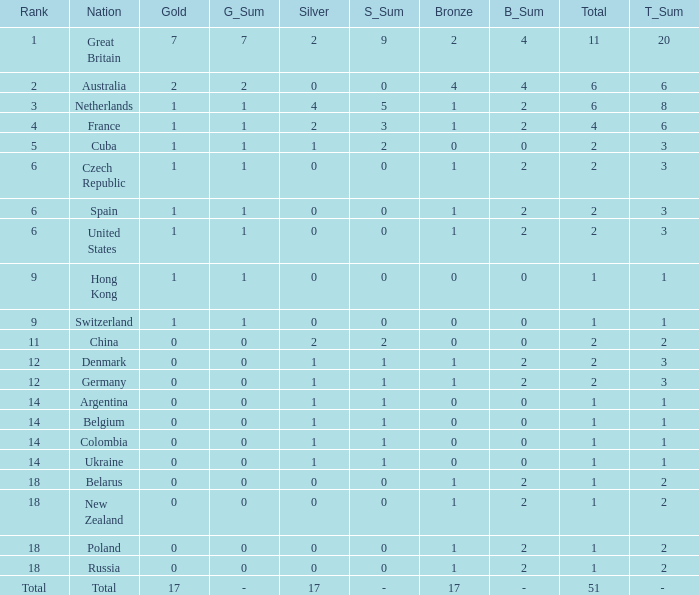Tell me the lowest gold for rank of 6 and total less than 2 None. 